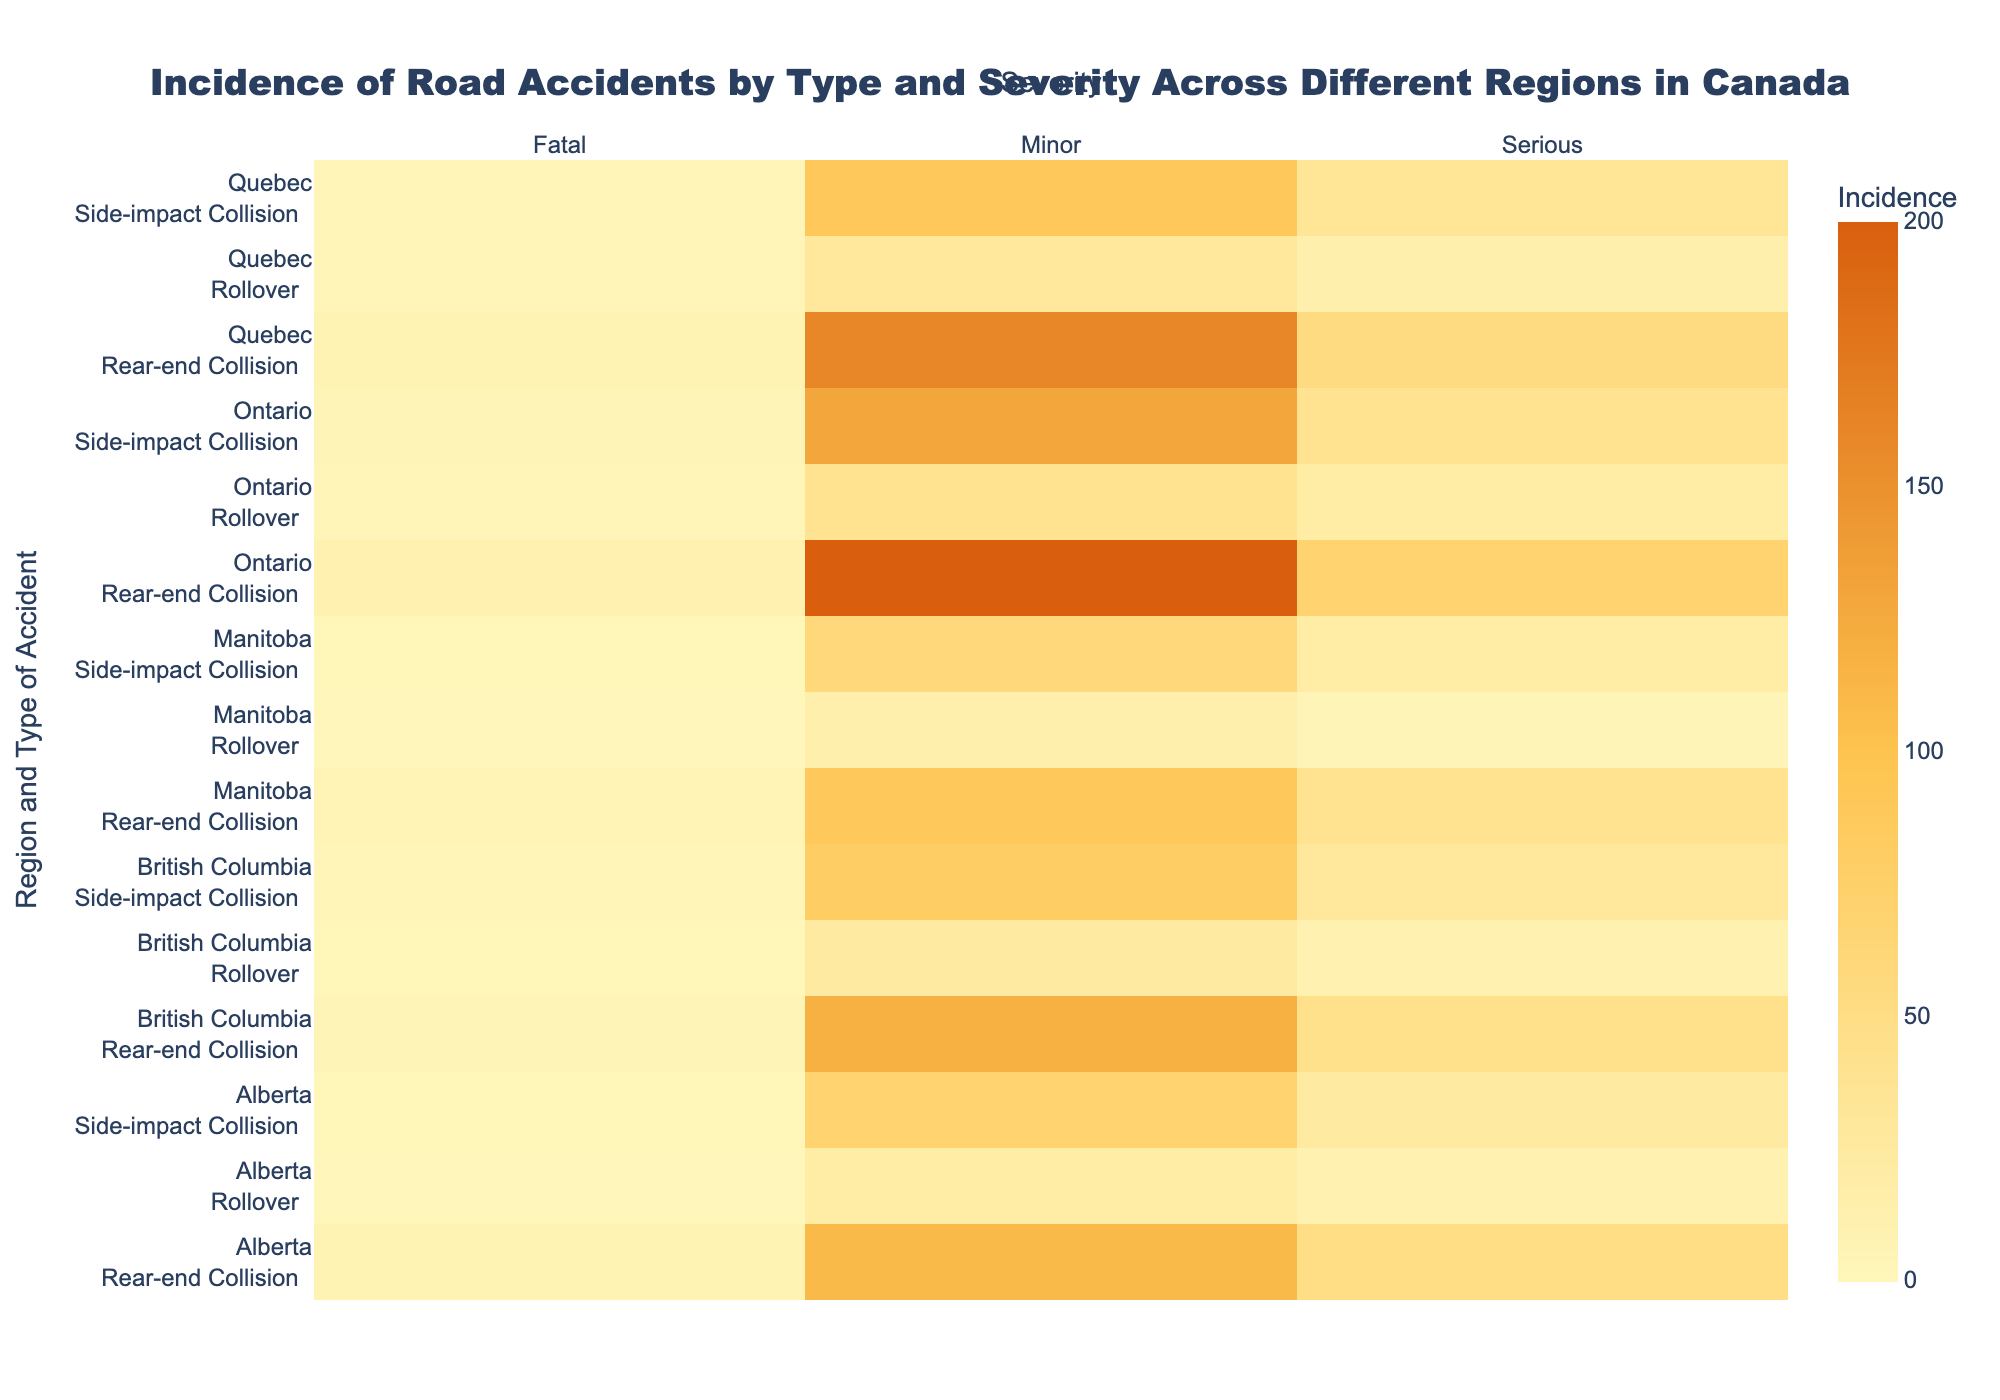Which region has the highest incidence of minor rear-end collisions? In the heatmap, look for the cells corresponding to "Minor" severity and "Rear-end Collision" for each region. The highest value among these cells is in Ontario.
Answer: Ontario How many serious side-impact collisions are there in British Columbia and Alberta combined? Identify the cells for "Serious" severity and "Side-impact Collision" in both British Columbia and Alberta rows. Sum the values (30 in British Columbia and 25 in Alberta) to get the total.
Answer: 55 Which type of accident has the lowest incidence of fatalities in Quebec? Look for the "Fatal" severity cells in the Quebec section. Compare the incidence values for each type of accident and find the lowest value, which is 3 for Rollovers.
Answer: Rollovers What is the total number of minor accidents in Ontario across all types? Identify the cells for "Minor" severity in the Ontario section for each type of accident ("Rear-end Collision," "Side-impact Collision," "Rollover"). Sum the values (200 + 130 + 40) to get the total.
Answer: 370 Which region has the lowest incidence of serious rear-end collisions? Compare the cells for "Serious" severity and "Rear-end Collision" across all regions. The lowest value is in Manitoba with 40.
Answer: Manitoba Is the incidence of serious rollovers in Quebec higher than in Manitoba? Compare the values in the heatmap for "Serious" severity and "Rollover" in Quebec and Manitoba. Quebec has 15 and Manitoba has 5, so the incidence is higher in Quebec.
Answer: Yes Which type of accident generally has the highest incidence of minor collisions across all regions? Sum the incidence of minor collisions for each type of accident across all regions. Compare the sums to determine which type has the highest total. Rear-end Collisions generally have the highest incidence overall.
Answer: Rear-end Collisions How does the incidence of fatal side-impact collisions in Ontario compare to Alberta? Identify the values for "Fatal" severity and "Side-impact Collision" in both Ontario and Alberta in the heatmap. Ontario has 5, while Alberta has 2. Ontario has a higher incidence.
Answer: Higher in Ontario What's the sum of fatal accidents in British Columbia for all types of accidents? Sum the values for "Fatal" severity in the British Columbia section for each type of accident (5 for Rear-end Collision, 3 for Side-impact Collision, 2 for Rollovers).
Answer: 10 